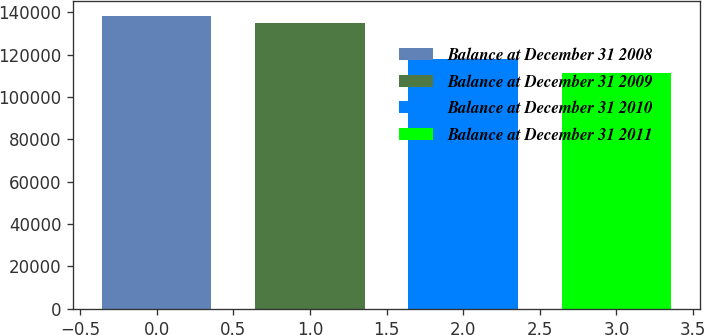Convert chart to OTSL. <chart><loc_0><loc_0><loc_500><loc_500><bar_chart><fcel>Balance at December 31 2008<fcel>Balance at December 31 2009<fcel>Balance at December 31 2010<fcel>Balance at December 31 2011<nl><fcel>138353<fcel>134967<fcel>118116<fcel>111127<nl></chart> 